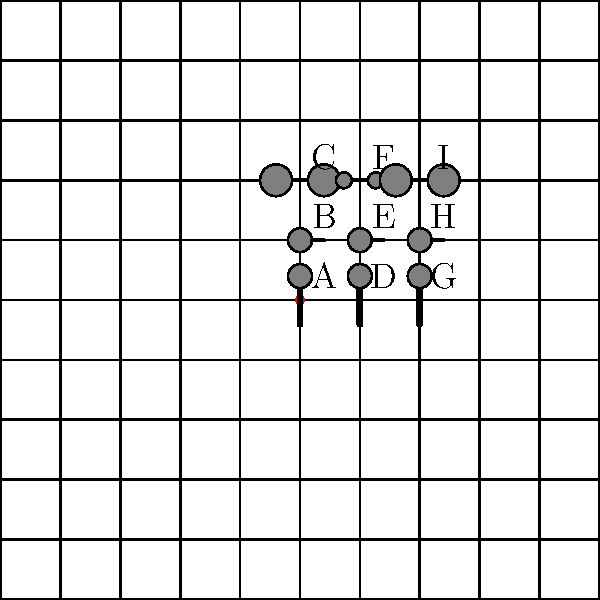Which of the items shown in the grid is most commonly used by simultaneous interpreters in conference settings? To answer this question, let's analyze the items shown in the grid:

1. Items A, D, and G are handheld microphones. These are typically used for speeches or interviews but not for simultaneous interpreting.

2. Items B, E, and H are lapel microphones. These are often used for presentations or TV broadcasts but are not ideal for interpreters who need their hands free.

3. Items C and F are headset microphones. These combine a microphone with headphones, which is crucial for simultaneous interpreters.

4. Items I is an over-ear headset, while C and F are in-ear headsets with attached microphones.

Simultaneous interpreters in conference settings typically require:
a) Headphones to hear the speaker clearly
b) A microphone to translate in real-time
c) Hands-free operation to take notes or use reference materials

The item that best meets all these requirements is the headset microphone (C and F). Between these two, the over-ear headset (I) is generally preferred in professional settings due to better sound isolation and comfort during long sessions.

Therefore, the item most commonly used by simultaneous interpreters in conference settings would be the over-ear headset with attached microphone, represented by item I in the grid.
Answer: I (Over-ear headset with microphone) 